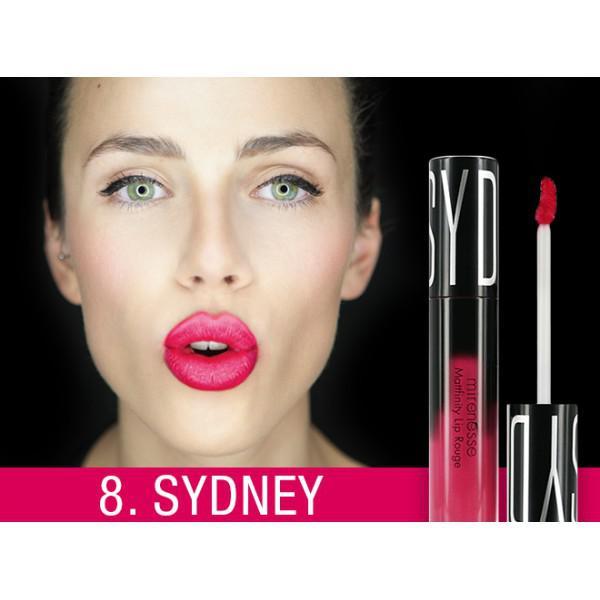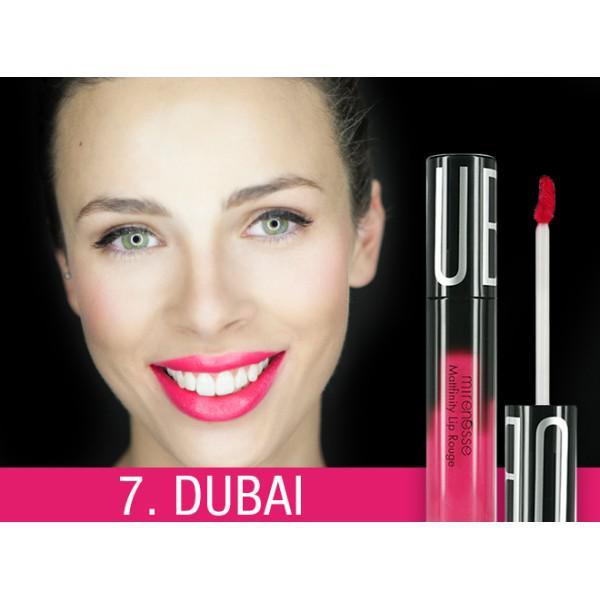The first image is the image on the left, the second image is the image on the right. For the images shown, is this caption "The woman's lips are closed in the image on the right." true? Answer yes or no. No. The first image is the image on the left, the second image is the image on the right. Considering the images on both sides, is "One image shows a model with tinted lips that are closed, so no teeth show." valid? Answer yes or no. No. 